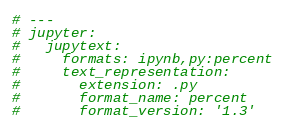<code> <loc_0><loc_0><loc_500><loc_500><_Python_># ---
# jupyter:
#   jupytext:
#     formats: ipynb,py:percent
#     text_representation:
#       extension: .py
#       format_name: percent
#       format_version: '1.3'</code> 